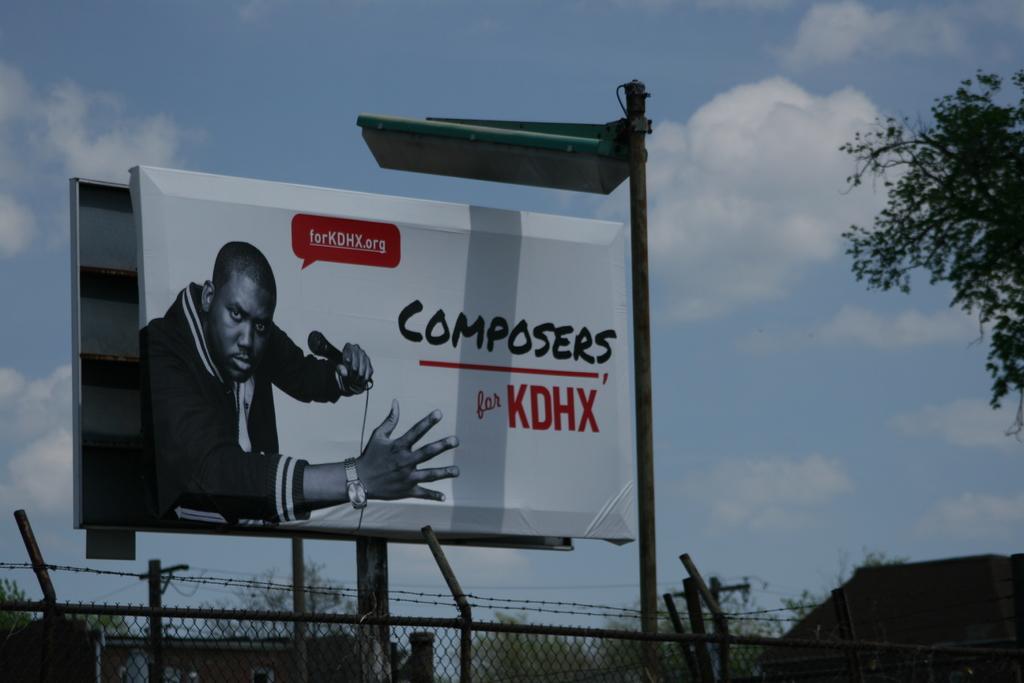Is this for kdhx?
Offer a terse response. Yes. What is the purpose of this billboard with composers on it?
Ensure brevity in your answer.  Unanswerable. 